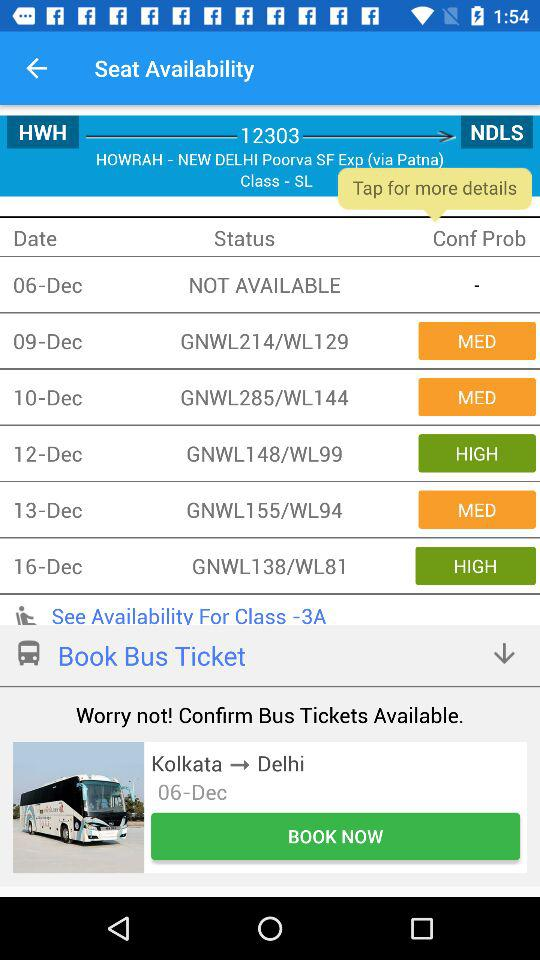Is there any seat available on 06-Dec? There is no seat available. 